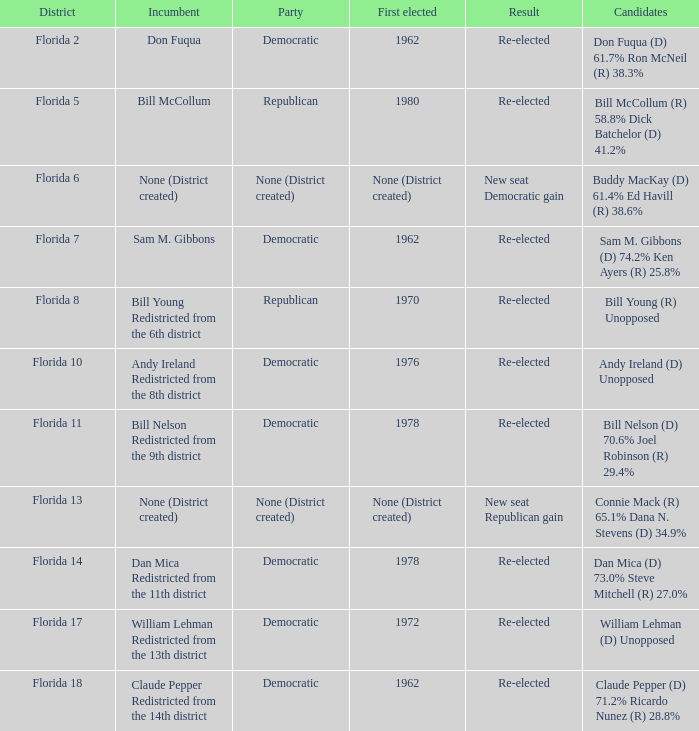Who is the the candidates with incumbent being don fuqua Don Fuqua (D) 61.7% Ron McNeil (R) 38.3%. 